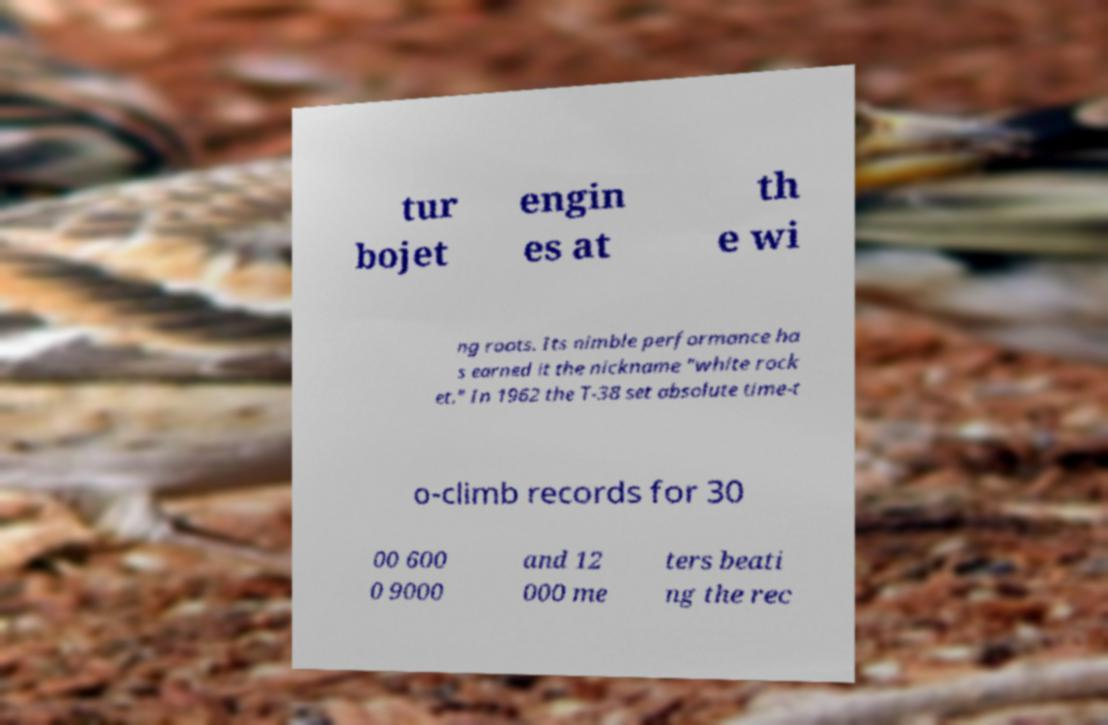Could you extract and type out the text from this image? tur bojet engin es at th e wi ng roots. Its nimble performance ha s earned it the nickname "white rock et." In 1962 the T-38 set absolute time-t o-climb records for 30 00 600 0 9000 and 12 000 me ters beati ng the rec 